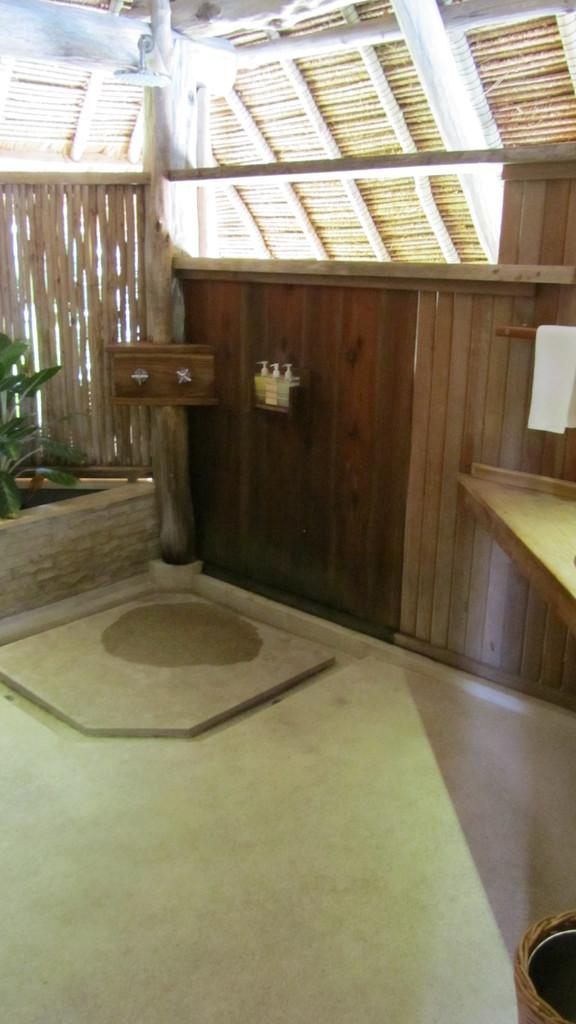Where was the image taken? The image is taken inside a shed. What type of plant can be seen in the image? There is a houseplant in the image. What is located at the bottom of the image? There is an object at the bottom of the image. What material is visible in the image? There is a cloth visible in the image. What value does the magic paper hold in the image? There is no magic paper present in the image, so it cannot hold any value. 